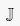Convert formula to latex. <formula><loc_0><loc_0><loc_500><loc_500>\mathbb { J }</formula> 